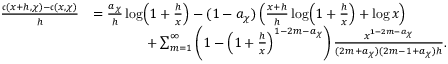Convert formula to latex. <formula><loc_0><loc_0><loc_500><loc_500>\begin{array} { r l } { \frac { \mathfrak { c } ( x + h , \chi ) - \mathfrak { c } ( x , \chi ) } { h } } & { = \frac { a _ { \chi } } { h } \log \, \left ( 1 + \frac { h } { x } \right ) - ( 1 - a _ { \chi } ) \left ( \frac { x + h } { h } \log \, \left ( 1 + \frac { h } { x } \right ) + \log { x } \right ) } \\ & { \quad + \sum _ { m = 1 } ^ { \infty } \left ( 1 - \left ( 1 + \frac { h } { x } \right ) ^ { 1 - 2 m - a _ { \chi } } \right ) \frac { x ^ { 1 - 2 m - a _ { \chi } } } { ( 2 m + a _ { \chi } ) ( 2 m - 1 + a _ { \chi } ) h } . } \end{array}</formula> 